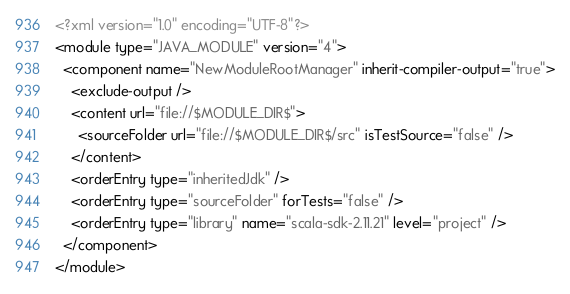<code> <loc_0><loc_0><loc_500><loc_500><_XML_><?xml version="1.0" encoding="UTF-8"?>
<module type="JAVA_MODULE" version="4">
  <component name="NewModuleRootManager" inherit-compiler-output="true">
    <exclude-output />
    <content url="file://$MODULE_DIR$">
      <sourceFolder url="file://$MODULE_DIR$/src" isTestSource="false" />
    </content>
    <orderEntry type="inheritedJdk" />
    <orderEntry type="sourceFolder" forTests="false" />
    <orderEntry type="library" name="scala-sdk-2.11.21" level="project" />
  </component>
</module></code> 